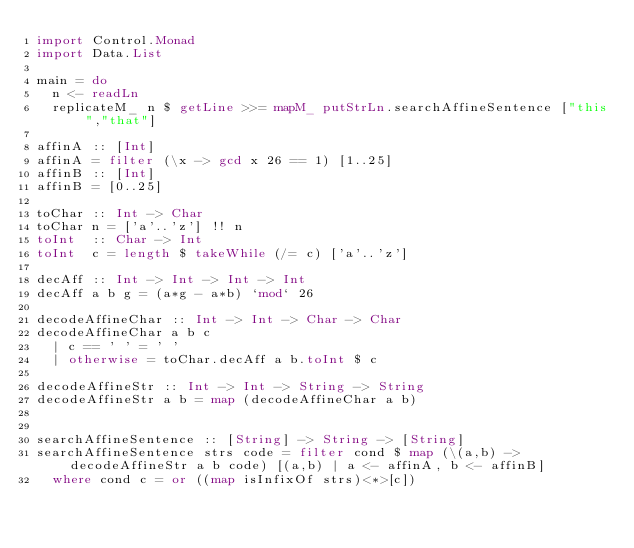Convert code to text. <code><loc_0><loc_0><loc_500><loc_500><_Haskell_>import Control.Monad
import Data.List

main = do
  n <- readLn
  replicateM_ n $ getLine >>= mapM_ putStrLn.searchAffineSentence ["this","that"]

affinA :: [Int]
affinA = filter (\x -> gcd x 26 == 1) [1..25]
affinB :: [Int]
affinB = [0..25]

toChar :: Int -> Char
toChar n = ['a'..'z'] !! n
toInt  :: Char -> Int
toInt  c = length $ takeWhile (/= c) ['a'..'z']

decAff :: Int -> Int -> Int -> Int
decAff a b g = (a*g - a*b) `mod` 26

decodeAffineChar :: Int -> Int -> Char -> Char
decodeAffineChar a b c
  | c == ' ' = ' '
  | otherwise = toChar.decAff a b.toInt $ c

decodeAffineStr :: Int -> Int -> String -> String
decodeAffineStr a b = map (decodeAffineChar a b)


searchAffineSentence :: [String] -> String -> [String]
searchAffineSentence strs code = filter cond $ map (\(a,b) -> decodeAffineStr a b code) [(a,b) | a <- affinA, b <- affinB]
  where cond c = or ((map isInfixOf strs)<*>[c])</code> 